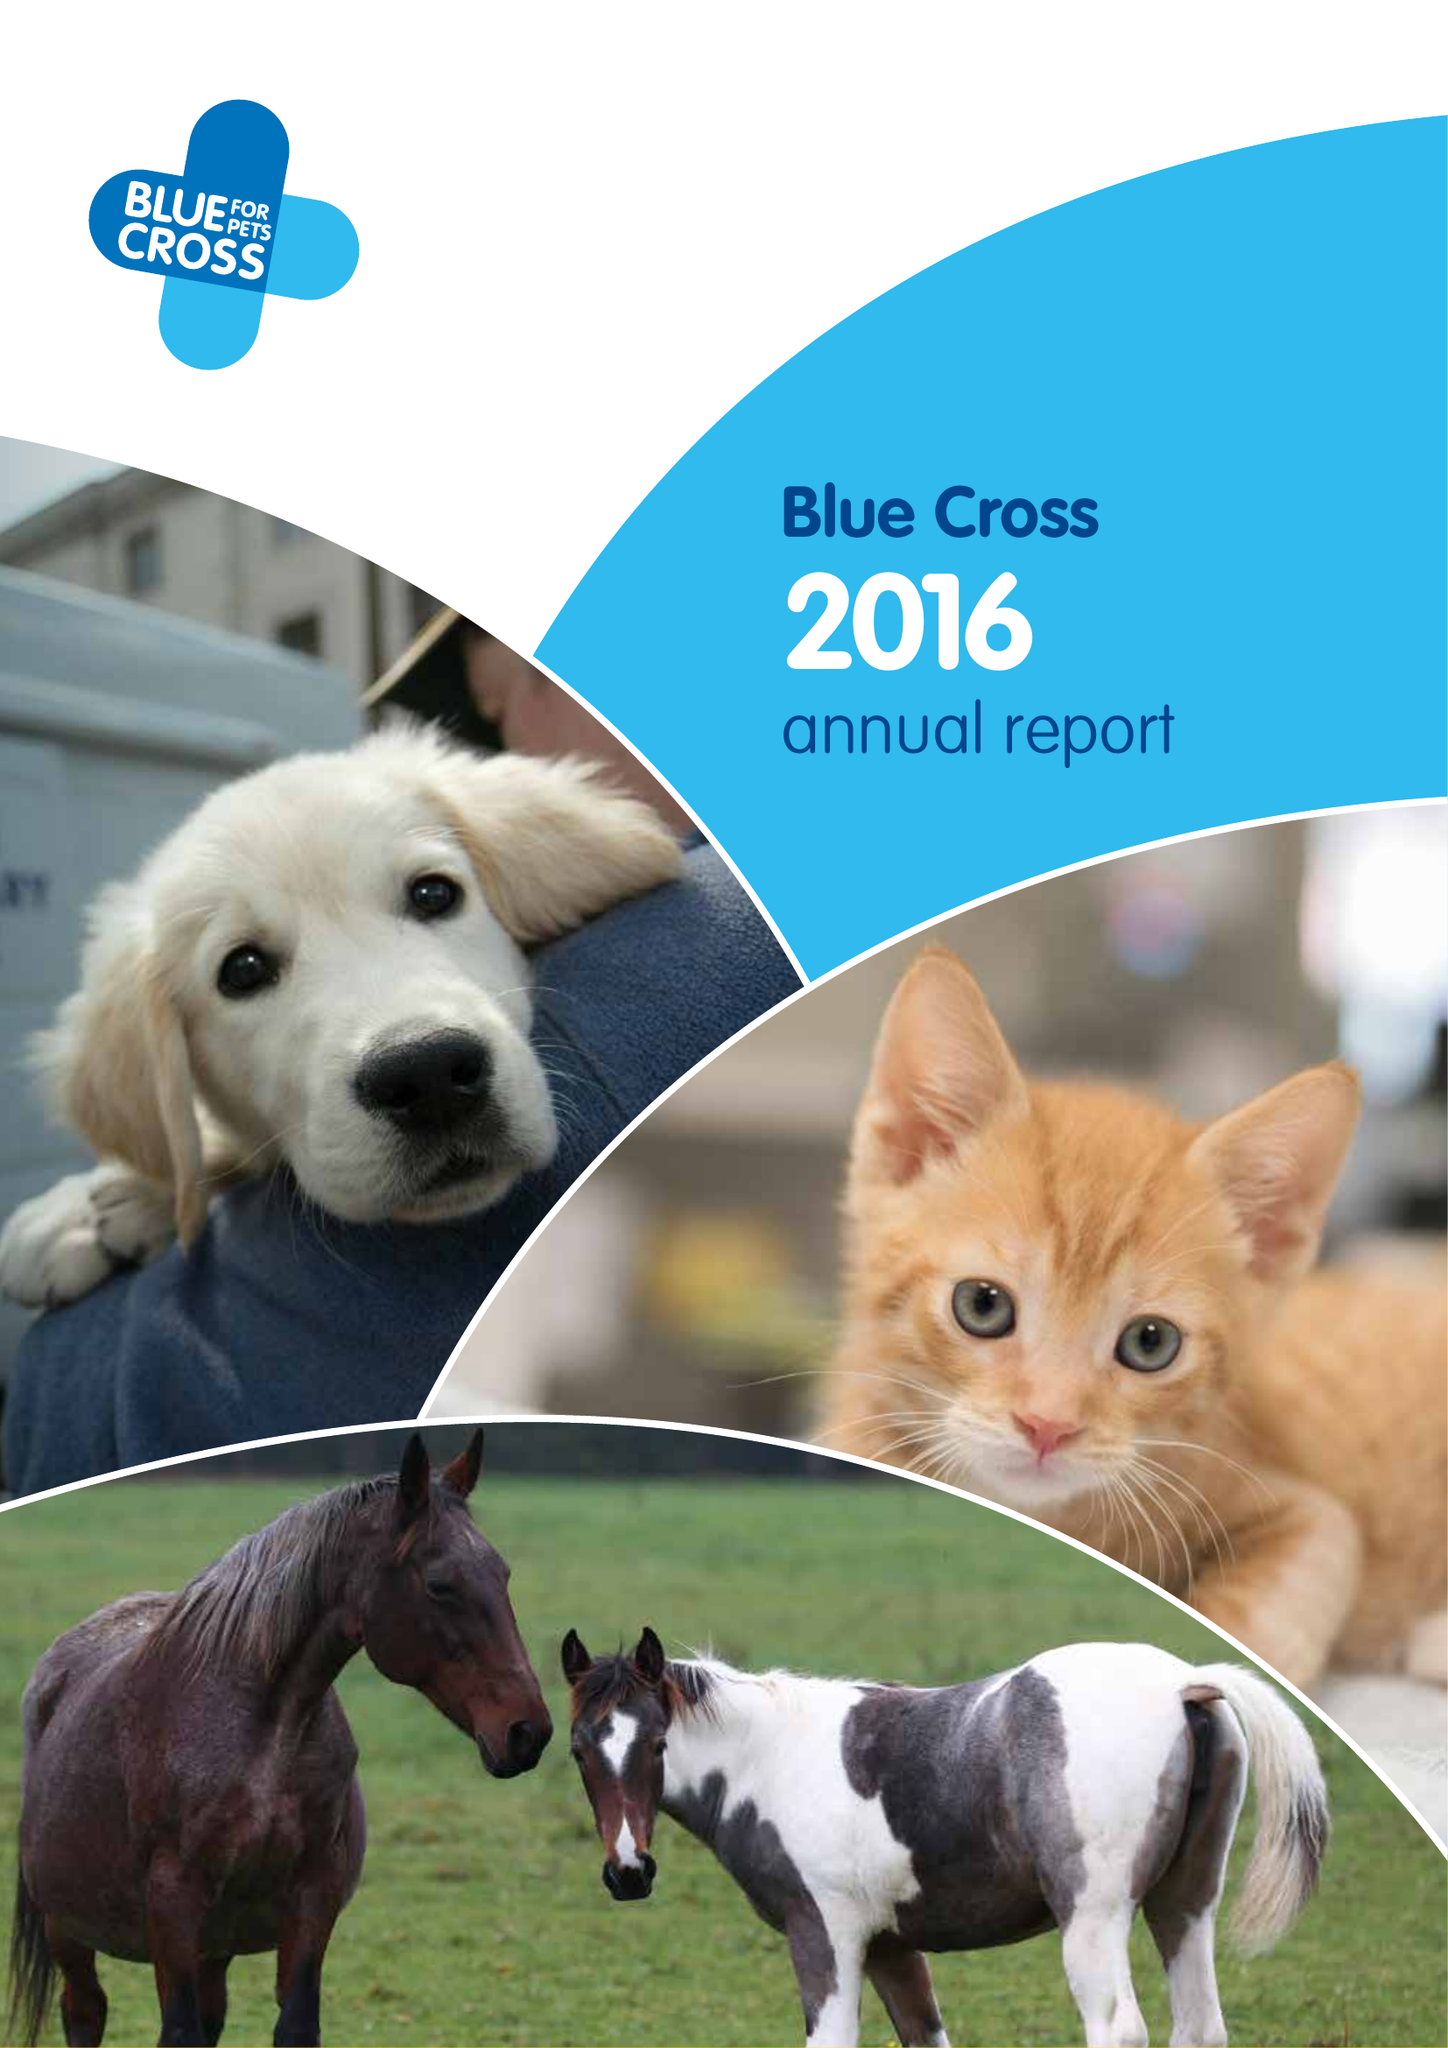What is the value for the spending_annually_in_british_pounds?
Answer the question using a single word or phrase. 37635000.00 